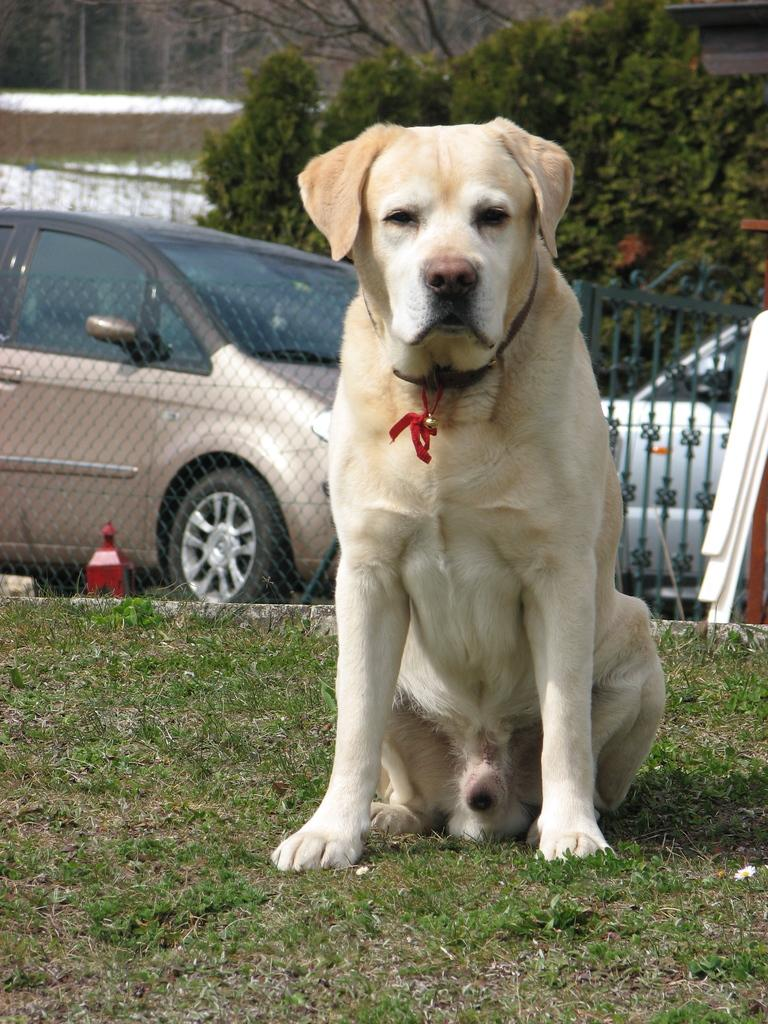What animal can be seen in the image? There is a dog in the image. Where is the dog located? The dog is sitting on grassy land. What type of barrier is present in the image? There is fencing in the image. What type of vehicle is visible in the image? There is a car in the image. What type of plant is present in the image? There is a tree in the image. What type of stem can be seen exchanging information with the dog in the image? There is no stem present in the image, nor is there any indication of information exchange between the dog and any other object. 